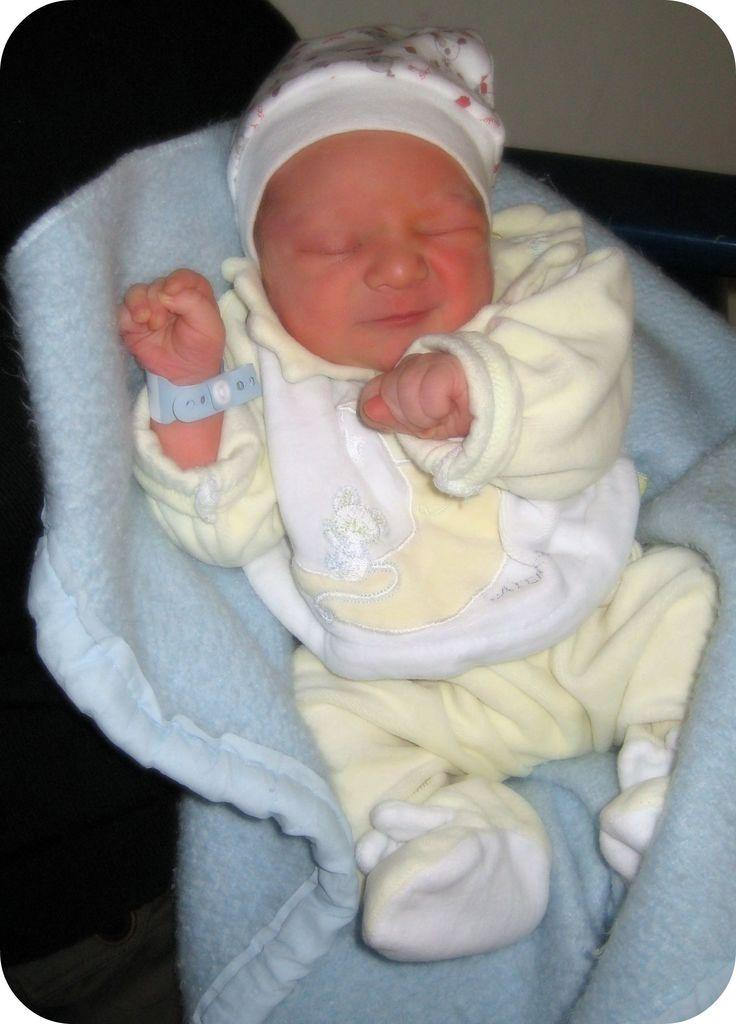What is the main subject of the image? There is a baby in the image. What is the baby positioned on? The baby is on a cloth. What is the baby wearing? The baby is wearing a yellow dress and a cap. What can be seen behind the baby? There is a wall behind the baby. What type of notebook is the baby holding in the image? There is no notebook present in the image; the baby is not holding anything. 